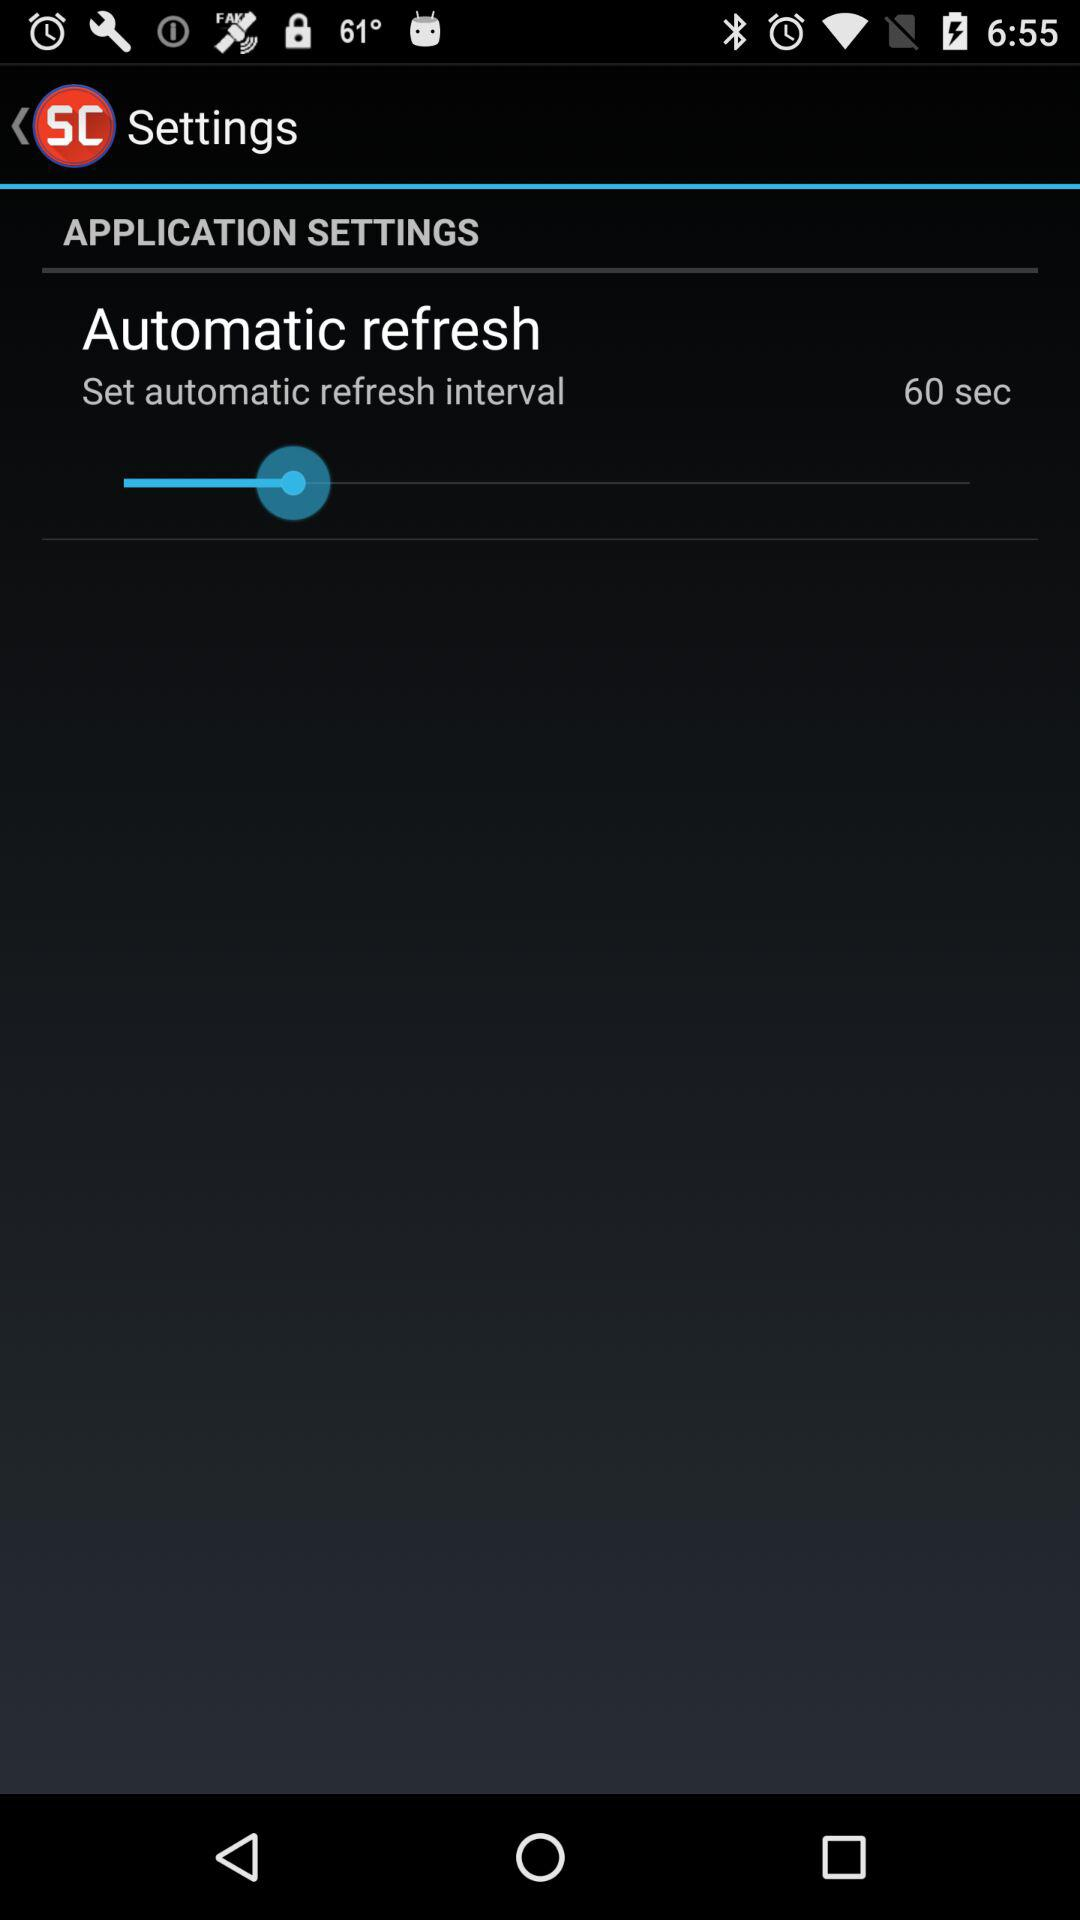What's the set duration of the automatic refresh interval? The set duration of the automatic refresh interval is 60 seconds. 